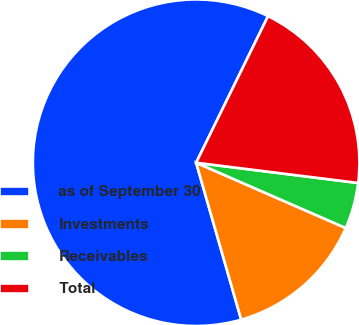Convert chart. <chart><loc_0><loc_0><loc_500><loc_500><pie_chart><fcel>as of September 30<fcel>Investments<fcel>Receivables<fcel>Total<nl><fcel>61.71%<fcel>14.0%<fcel>4.57%<fcel>19.72%<nl></chart> 